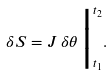Convert formula to latex. <formula><loc_0><loc_0><loc_500><loc_500>\delta S = J \, \delta \theta \, \Big | _ { t _ { 1 } } ^ { t _ { 2 } } .</formula> 